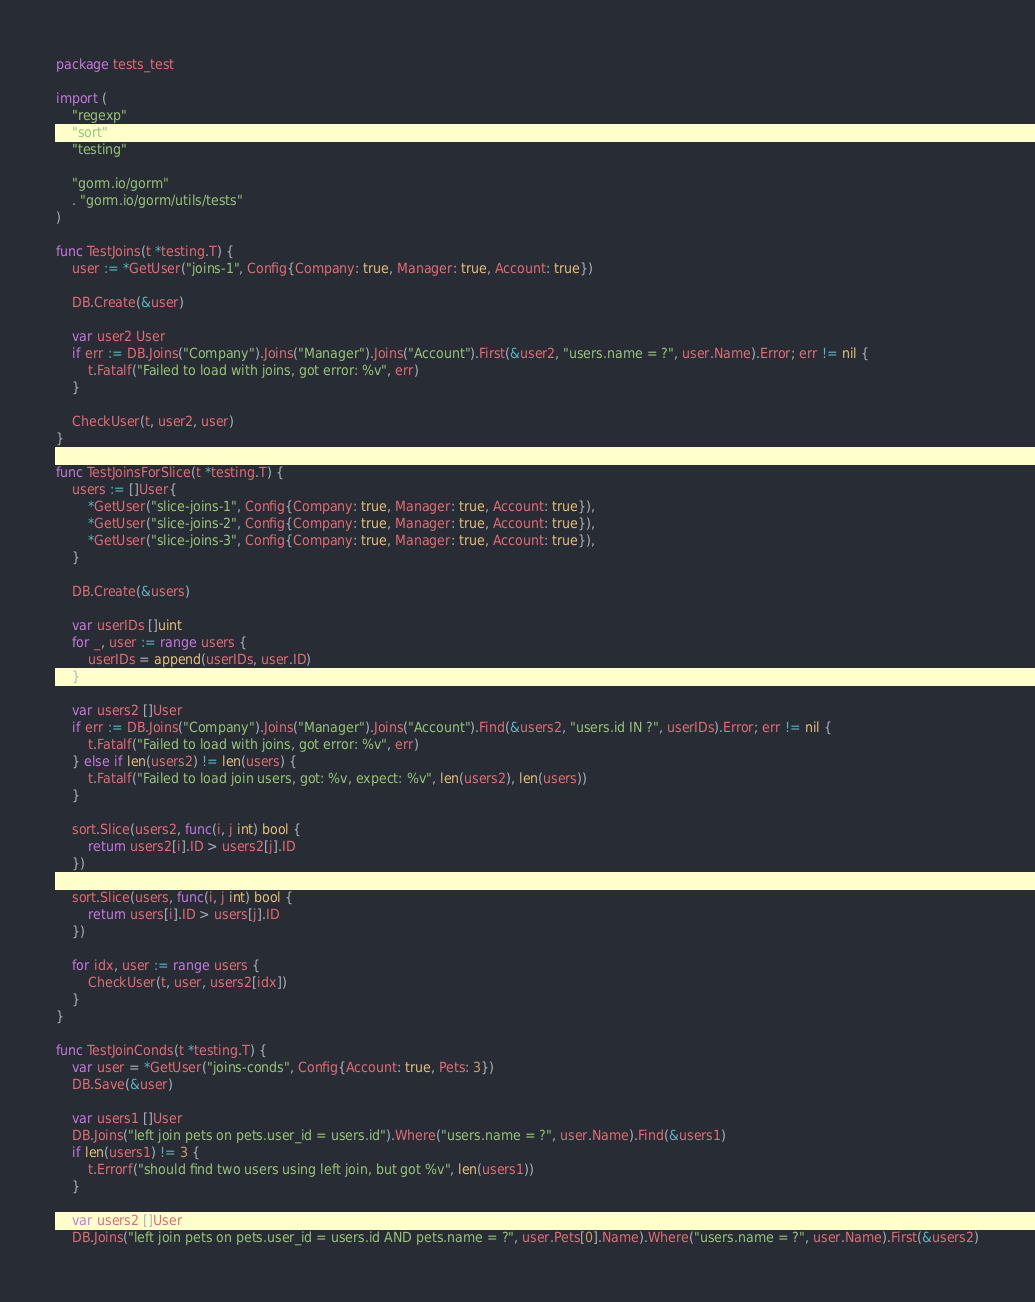<code> <loc_0><loc_0><loc_500><loc_500><_Go_>package tests_test

import (
	"regexp"
	"sort"
	"testing"

	"gorm.io/gorm"
	. "gorm.io/gorm/utils/tests"
)

func TestJoins(t *testing.T) {
	user := *GetUser("joins-1", Config{Company: true, Manager: true, Account: true})

	DB.Create(&user)

	var user2 User
	if err := DB.Joins("Company").Joins("Manager").Joins("Account").First(&user2, "users.name = ?", user.Name).Error; err != nil {
		t.Fatalf("Failed to load with joins, got error: %v", err)
	}

	CheckUser(t, user2, user)
}

func TestJoinsForSlice(t *testing.T) {
	users := []User{
		*GetUser("slice-joins-1", Config{Company: true, Manager: true, Account: true}),
		*GetUser("slice-joins-2", Config{Company: true, Manager: true, Account: true}),
		*GetUser("slice-joins-3", Config{Company: true, Manager: true, Account: true}),
	}

	DB.Create(&users)

	var userIDs []uint
	for _, user := range users {
		userIDs = append(userIDs, user.ID)
	}

	var users2 []User
	if err := DB.Joins("Company").Joins("Manager").Joins("Account").Find(&users2, "users.id IN ?", userIDs).Error; err != nil {
		t.Fatalf("Failed to load with joins, got error: %v", err)
	} else if len(users2) != len(users) {
		t.Fatalf("Failed to load join users, got: %v, expect: %v", len(users2), len(users))
	}

	sort.Slice(users2, func(i, j int) bool {
		return users2[i].ID > users2[j].ID
	})

	sort.Slice(users, func(i, j int) bool {
		return users[i].ID > users[j].ID
	})

	for idx, user := range users {
		CheckUser(t, user, users2[idx])
	}
}

func TestJoinConds(t *testing.T) {
	var user = *GetUser("joins-conds", Config{Account: true, Pets: 3})
	DB.Save(&user)

	var users1 []User
	DB.Joins("left join pets on pets.user_id = users.id").Where("users.name = ?", user.Name).Find(&users1)
	if len(users1) != 3 {
		t.Errorf("should find two users using left join, but got %v", len(users1))
	}

	var users2 []User
	DB.Joins("left join pets on pets.user_id = users.id AND pets.name = ?", user.Pets[0].Name).Where("users.name = ?", user.Name).First(&users2)</code> 